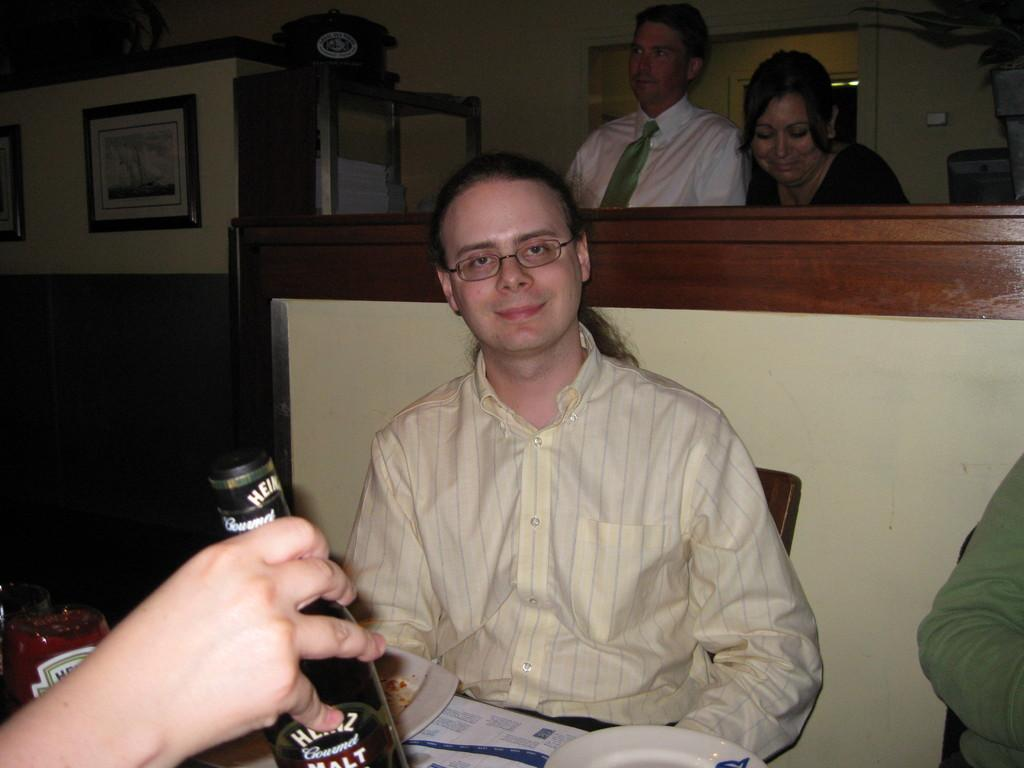What is the man in the image doing? The man is sitting on a chair in the image. What is in front of the man? There is a table in front of the man. What can be seen on the table? There is a wine bottle on the table, along with other objects. Are there any other people in the image? Yes, there are people standing at the back. What type of toothpaste is the man using in the image? There is no toothpaste present in the image, as it features a man sitting on a chair with a table and other objects in front of him. 